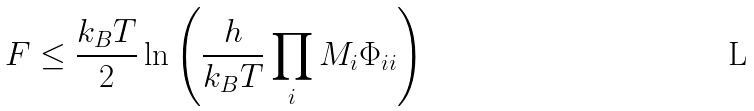Convert formula to latex. <formula><loc_0><loc_0><loc_500><loc_500>F \leq \frac { k _ { B } T } { 2 } \ln \left ( \frac { h } { k _ { B } T } \prod _ { i } M _ { i } \Phi _ { i i } \right )</formula> 